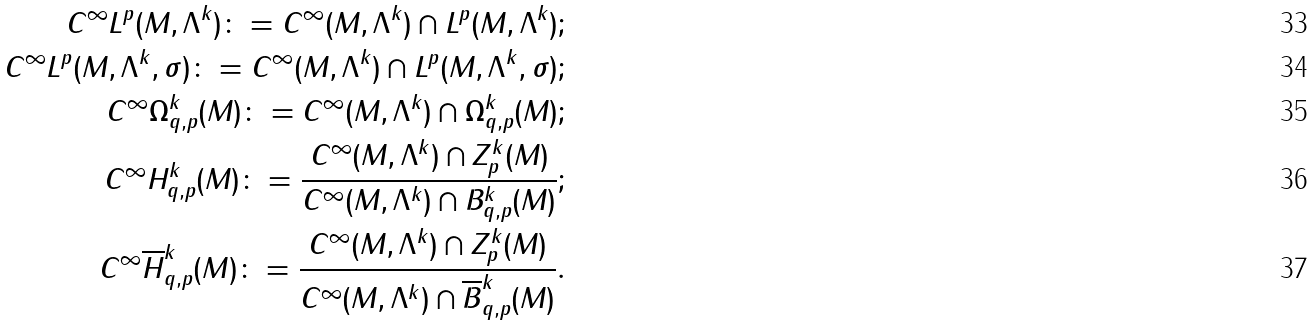Convert formula to latex. <formula><loc_0><loc_0><loc_500><loc_500>C ^ { \infty } L ^ { p } ( M , \Lambda ^ { k } ) \colon = C ^ { \infty } ( M , \Lambda ^ { k } ) \cap L ^ { p } ( M , \Lambda ^ { k } ) ; \\ C ^ { \infty } L ^ { p } ( M , \Lambda ^ { k } , \sigma ) \colon = C ^ { \infty } ( M , \Lambda ^ { k } ) \cap L ^ { p } ( M , \Lambda ^ { k } , \sigma ) ; \\ C ^ { \infty } \Omega _ { q , p } ^ { k } ( M ) \colon = C ^ { \infty } ( M , \Lambda ^ { k } ) \cap \Omega _ { q , p } ^ { k } ( M ) ; \\ C ^ { \infty } H _ { q , p } ^ { k } ( M ) \colon = \frac { C ^ { \infty } ( M , \Lambda ^ { k } ) \cap Z _ { p } ^ { k } ( M ) } { C ^ { \infty } ( M , \Lambda ^ { k } ) \cap B _ { q , p } ^ { k } ( M ) } ; \\ C ^ { \infty } \overline { H } _ { q , p } ^ { k } ( M ) \colon = \frac { C ^ { \infty } ( M , \Lambda ^ { k } ) \cap Z _ { p } ^ { k } ( M ) } { C ^ { \infty } ( M , \Lambda ^ { k } ) \cap \overline { B } _ { q , p } ^ { k } ( M ) } .</formula> 